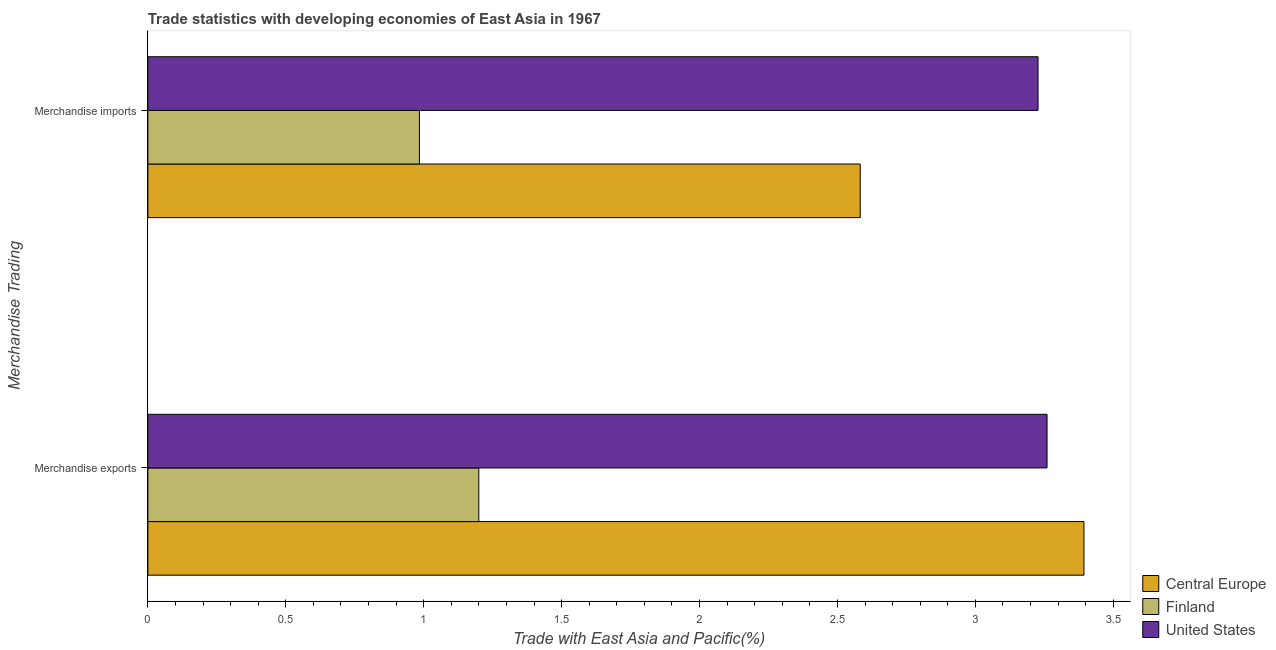How many groups of bars are there?
Your answer should be very brief. 2. How many bars are there on the 2nd tick from the bottom?
Your answer should be compact. 3. What is the merchandise imports in Central Europe?
Your answer should be very brief. 2.58. Across all countries, what is the maximum merchandise imports?
Offer a terse response. 3.23. Across all countries, what is the minimum merchandise imports?
Your response must be concise. 0.98. In which country was the merchandise imports minimum?
Provide a short and direct response. Finland. What is the total merchandise imports in the graph?
Offer a terse response. 6.79. What is the difference between the merchandise imports in United States and that in Finland?
Your answer should be compact. 2.24. What is the difference between the merchandise imports in Central Europe and the merchandise exports in United States?
Give a very brief answer. -0.68. What is the average merchandise imports per country?
Keep it short and to the point. 2.26. What is the difference between the merchandise imports and merchandise exports in United States?
Provide a succinct answer. -0.03. In how many countries, is the merchandise exports greater than 2.9 %?
Provide a short and direct response. 2. What is the ratio of the merchandise exports in Finland to that in United States?
Make the answer very short. 0.37. Is the merchandise imports in United States less than that in Finland?
Your answer should be compact. No. What does the 1st bar from the top in Merchandise imports represents?
Provide a succinct answer. United States. What does the 1st bar from the bottom in Merchandise imports represents?
Give a very brief answer. Central Europe. How many bars are there?
Ensure brevity in your answer.  6. How many countries are there in the graph?
Your answer should be very brief. 3. Are the values on the major ticks of X-axis written in scientific E-notation?
Keep it short and to the point. No. Does the graph contain any zero values?
Ensure brevity in your answer.  No. Does the graph contain grids?
Your response must be concise. No. Where does the legend appear in the graph?
Your response must be concise. Bottom right. What is the title of the graph?
Provide a short and direct response. Trade statistics with developing economies of East Asia in 1967. What is the label or title of the X-axis?
Your answer should be compact. Trade with East Asia and Pacific(%). What is the label or title of the Y-axis?
Offer a terse response. Merchandise Trading. What is the Trade with East Asia and Pacific(%) in Central Europe in Merchandise exports?
Provide a short and direct response. 3.39. What is the Trade with East Asia and Pacific(%) in Finland in Merchandise exports?
Your response must be concise. 1.2. What is the Trade with East Asia and Pacific(%) in United States in Merchandise exports?
Your answer should be compact. 3.26. What is the Trade with East Asia and Pacific(%) in Central Europe in Merchandise imports?
Your answer should be very brief. 2.58. What is the Trade with East Asia and Pacific(%) in Finland in Merchandise imports?
Ensure brevity in your answer.  0.98. What is the Trade with East Asia and Pacific(%) of United States in Merchandise imports?
Your answer should be very brief. 3.23. Across all Merchandise Trading, what is the maximum Trade with East Asia and Pacific(%) in Central Europe?
Offer a very short reply. 3.39. Across all Merchandise Trading, what is the maximum Trade with East Asia and Pacific(%) in Finland?
Give a very brief answer. 1.2. Across all Merchandise Trading, what is the maximum Trade with East Asia and Pacific(%) in United States?
Give a very brief answer. 3.26. Across all Merchandise Trading, what is the minimum Trade with East Asia and Pacific(%) in Central Europe?
Your answer should be compact. 2.58. Across all Merchandise Trading, what is the minimum Trade with East Asia and Pacific(%) of Finland?
Your response must be concise. 0.98. Across all Merchandise Trading, what is the minimum Trade with East Asia and Pacific(%) of United States?
Make the answer very short. 3.23. What is the total Trade with East Asia and Pacific(%) of Central Europe in the graph?
Your answer should be very brief. 5.98. What is the total Trade with East Asia and Pacific(%) in Finland in the graph?
Give a very brief answer. 2.18. What is the total Trade with East Asia and Pacific(%) in United States in the graph?
Keep it short and to the point. 6.49. What is the difference between the Trade with East Asia and Pacific(%) of Central Europe in Merchandise exports and that in Merchandise imports?
Your response must be concise. 0.81. What is the difference between the Trade with East Asia and Pacific(%) in Finland in Merchandise exports and that in Merchandise imports?
Offer a terse response. 0.22. What is the difference between the Trade with East Asia and Pacific(%) in United States in Merchandise exports and that in Merchandise imports?
Provide a short and direct response. 0.03. What is the difference between the Trade with East Asia and Pacific(%) of Central Europe in Merchandise exports and the Trade with East Asia and Pacific(%) of Finland in Merchandise imports?
Keep it short and to the point. 2.41. What is the difference between the Trade with East Asia and Pacific(%) of Central Europe in Merchandise exports and the Trade with East Asia and Pacific(%) of United States in Merchandise imports?
Make the answer very short. 0.17. What is the difference between the Trade with East Asia and Pacific(%) of Finland in Merchandise exports and the Trade with East Asia and Pacific(%) of United States in Merchandise imports?
Offer a terse response. -2.03. What is the average Trade with East Asia and Pacific(%) of Central Europe per Merchandise Trading?
Your response must be concise. 2.99. What is the average Trade with East Asia and Pacific(%) of Finland per Merchandise Trading?
Give a very brief answer. 1.09. What is the average Trade with East Asia and Pacific(%) of United States per Merchandise Trading?
Keep it short and to the point. 3.24. What is the difference between the Trade with East Asia and Pacific(%) of Central Europe and Trade with East Asia and Pacific(%) of Finland in Merchandise exports?
Your answer should be compact. 2.19. What is the difference between the Trade with East Asia and Pacific(%) of Central Europe and Trade with East Asia and Pacific(%) of United States in Merchandise exports?
Give a very brief answer. 0.13. What is the difference between the Trade with East Asia and Pacific(%) of Finland and Trade with East Asia and Pacific(%) of United States in Merchandise exports?
Ensure brevity in your answer.  -2.06. What is the difference between the Trade with East Asia and Pacific(%) of Central Europe and Trade with East Asia and Pacific(%) of Finland in Merchandise imports?
Make the answer very short. 1.6. What is the difference between the Trade with East Asia and Pacific(%) of Central Europe and Trade with East Asia and Pacific(%) of United States in Merchandise imports?
Your answer should be very brief. -0.64. What is the difference between the Trade with East Asia and Pacific(%) of Finland and Trade with East Asia and Pacific(%) of United States in Merchandise imports?
Keep it short and to the point. -2.24. What is the ratio of the Trade with East Asia and Pacific(%) of Central Europe in Merchandise exports to that in Merchandise imports?
Keep it short and to the point. 1.31. What is the ratio of the Trade with East Asia and Pacific(%) in Finland in Merchandise exports to that in Merchandise imports?
Your answer should be compact. 1.22. What is the difference between the highest and the second highest Trade with East Asia and Pacific(%) in Central Europe?
Make the answer very short. 0.81. What is the difference between the highest and the second highest Trade with East Asia and Pacific(%) of Finland?
Give a very brief answer. 0.22. What is the difference between the highest and the second highest Trade with East Asia and Pacific(%) of United States?
Offer a very short reply. 0.03. What is the difference between the highest and the lowest Trade with East Asia and Pacific(%) of Central Europe?
Offer a terse response. 0.81. What is the difference between the highest and the lowest Trade with East Asia and Pacific(%) in Finland?
Provide a short and direct response. 0.22. What is the difference between the highest and the lowest Trade with East Asia and Pacific(%) in United States?
Make the answer very short. 0.03. 